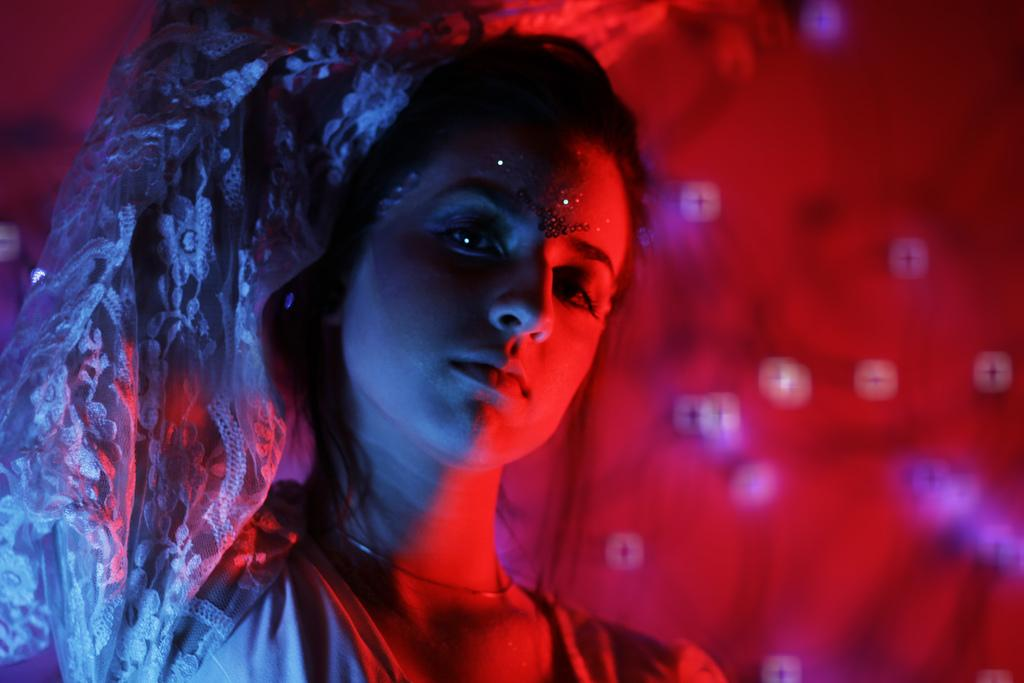Who is the main subject in the image? There is a woman in the image. What color is the background of the image? The background of the image is red. What type of test is the woman conducting in the image? There is no indication of a test or any testing activity in the image. 